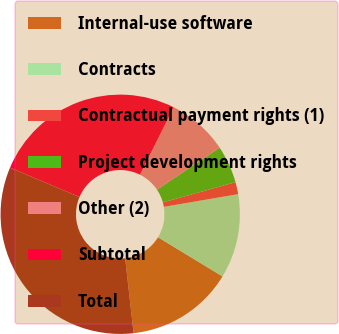Convert chart to OTSL. <chart><loc_0><loc_0><loc_500><loc_500><pie_chart><fcel>Internal-use software<fcel>Contracts<fcel>Contractual payment rights (1)<fcel>Project development rights<fcel>Other (2)<fcel>Subtotal<fcel>Total<nl><fcel>14.53%<fcel>11.38%<fcel>1.63%<fcel>5.07%<fcel>8.23%<fcel>26.0%<fcel>33.16%<nl></chart> 